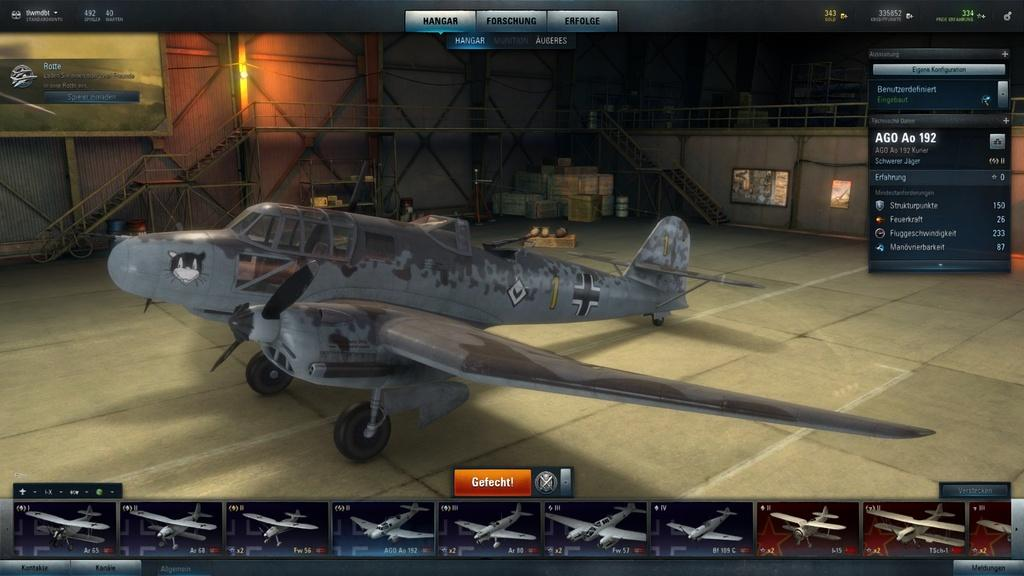<image>
Describe the image concisely. a game with a plane in a hanger with the number one on it 